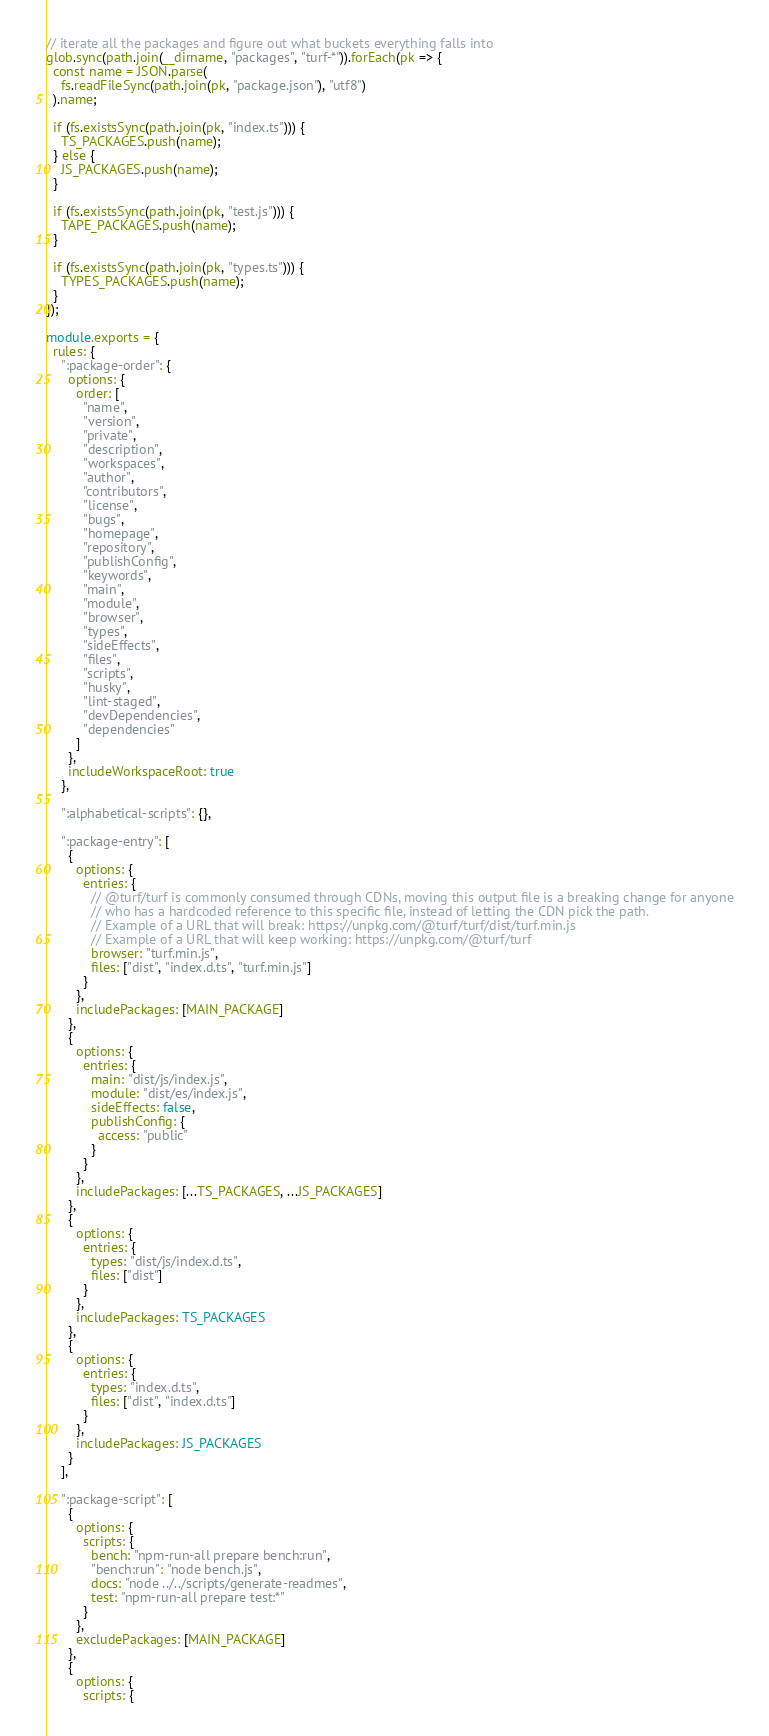Convert code to text. <code><loc_0><loc_0><loc_500><loc_500><_TypeScript_>
// iterate all the packages and figure out what buckets everything falls into
glob.sync(path.join(__dirname, "packages", "turf-*")).forEach(pk => {
  const name = JSON.parse(
    fs.readFileSync(path.join(pk, "package.json"), "utf8")
  ).name;

  if (fs.existsSync(path.join(pk, "index.ts"))) {
    TS_PACKAGES.push(name);
  } else {
    JS_PACKAGES.push(name);
  }

  if (fs.existsSync(path.join(pk, "test.js"))) {
    TAPE_PACKAGES.push(name);
  }

  if (fs.existsSync(path.join(pk, "types.ts"))) {
    TYPES_PACKAGES.push(name);
  }
});

module.exports = {
  rules: {
    ":package-order": {
      options: {
        order: [
          "name",
          "version",
          "private",
          "description",
          "workspaces",
          "author",
          "contributors",
          "license",
          "bugs",
          "homepage",
          "repository",
          "publishConfig",
          "keywords",
          "main",
          "module",
          "browser",
          "types",
          "sideEffects",
          "files",
          "scripts",
          "husky",
          "lint-staged",
          "devDependencies",
          "dependencies"
        ]
      },
      includeWorkspaceRoot: true
    },

    ":alphabetical-scripts": {},

    ":package-entry": [
      {
        options: {
          entries: {
            // @turf/turf is commonly consumed through CDNs, moving this output file is a breaking change for anyone
            // who has a hardcoded reference to this specific file, instead of letting the CDN pick the path.
            // Example of a URL that will break: https://unpkg.com/@turf/turf/dist/turf.min.js
            // Example of a URL that will keep working: https://unpkg.com/@turf/turf
            browser: "turf.min.js",
            files: ["dist", "index.d.ts", "turf.min.js"]
          }
        },
        includePackages: [MAIN_PACKAGE]
      },
      {
        options: {
          entries: {
            main: "dist/js/index.js",
            module: "dist/es/index.js",
            sideEffects: false,
            publishConfig: {
              access: "public"
            }
          }
        },
        includePackages: [...TS_PACKAGES, ...JS_PACKAGES]
      },
      {
        options: {
          entries: {
            types: "dist/js/index.d.ts",
            files: ["dist"]
          }
        },
        includePackages: TS_PACKAGES
      },
      {
        options: {
          entries: {
            types: "index.d.ts",
            files: ["dist", "index.d.ts"]
          }
        },
        includePackages: JS_PACKAGES
      }
    ],

    ":package-script": [
      {
        options: {
          scripts: {
            bench: "npm-run-all prepare bench:run",
            "bench:run": "node bench.js",
            docs: "node ../../scripts/generate-readmes",
            test: "npm-run-all prepare test:*"
          }
        },
        excludePackages: [MAIN_PACKAGE]
      },
      {
        options: {
          scripts: {</code> 